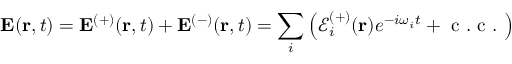Convert formula to latex. <formula><loc_0><loc_0><loc_500><loc_500>E ( r , t ) = E ^ { ( + ) } ( r , t ) + E ^ { ( - ) } ( r , t ) = \sum _ { i } \left ( \mathcal { E } _ { i } ^ { ( + ) } ( r ) e ^ { - i \omega _ { i } t } + c . c . \right )</formula> 